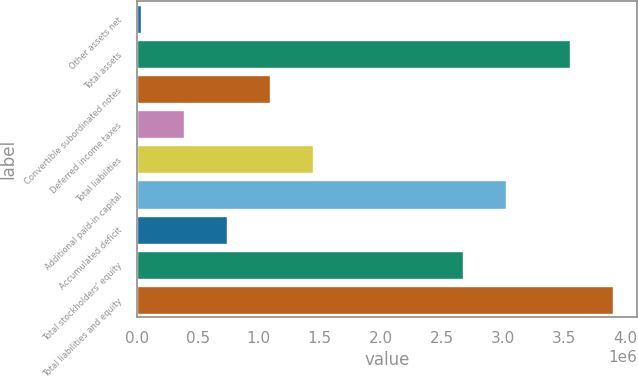<chart> <loc_0><loc_0><loc_500><loc_500><bar_chart><fcel>Other assets net<fcel>Total assets<fcel>Convertible subordinated notes<fcel>Deferred income taxes<fcel>Total liabilities<fcel>Additional paid-in capital<fcel>Accumulated deficit<fcel>Total stockholders' equity<fcel>Total liabilities and equity<nl><fcel>33479<fcel>3.55424e+06<fcel>1.08971e+06<fcel>385555<fcel>1.44178e+06<fcel>3.02329e+06<fcel>737632<fcel>2.67122e+06<fcel>3.90632e+06<nl></chart> 